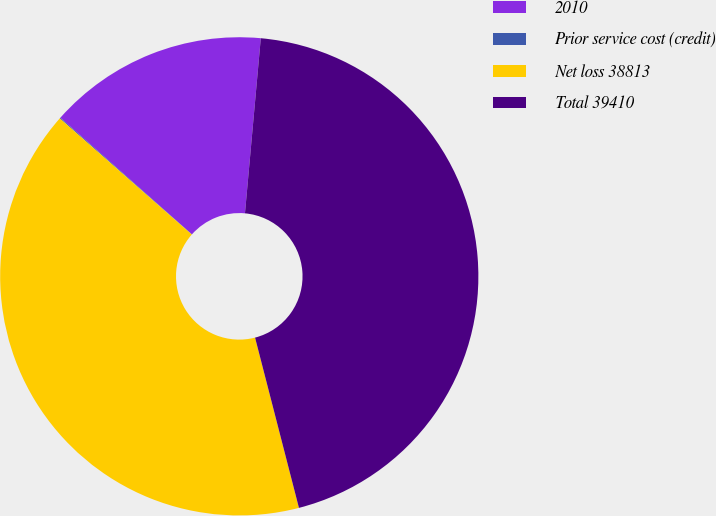Convert chart. <chart><loc_0><loc_0><loc_500><loc_500><pie_chart><fcel>2010<fcel>Prior service cost (credit)<fcel>Net loss 38813<fcel>Total 39410<nl><fcel>14.89%<fcel>0.06%<fcel>40.5%<fcel>44.55%<nl></chart> 